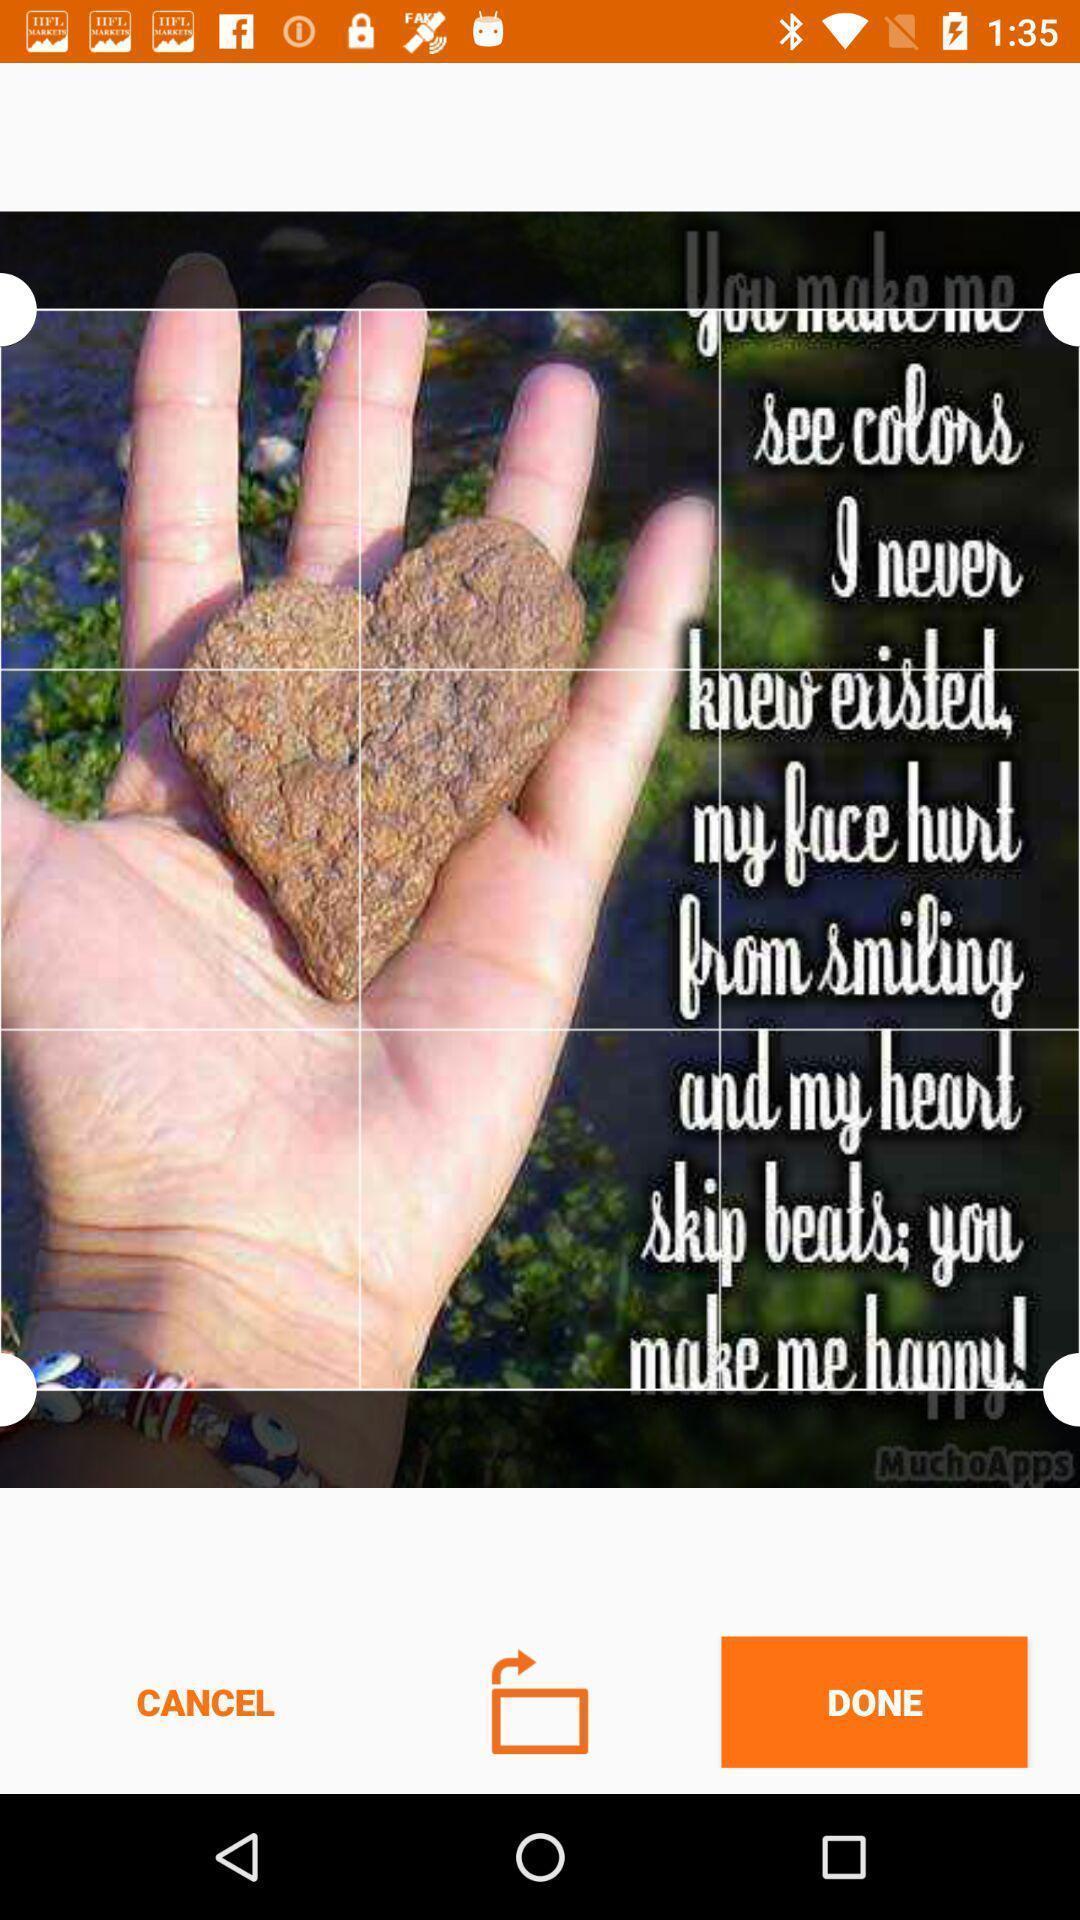Give me a summary of this screen capture. Screen showing image editing page. 